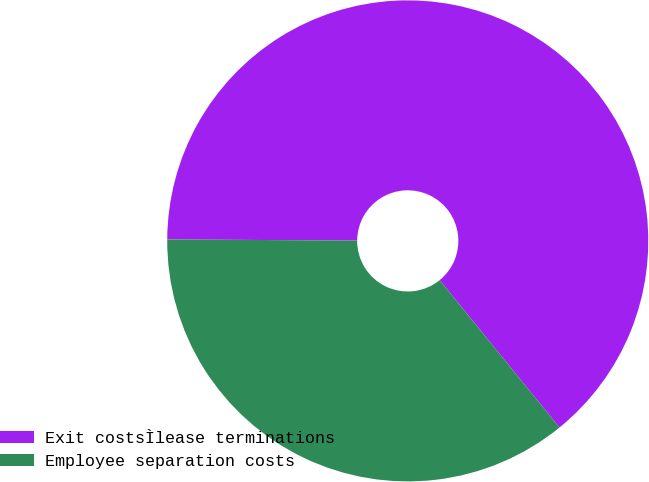Convert chart. <chart><loc_0><loc_0><loc_500><loc_500><pie_chart><fcel>Exit costsÌlease terminations<fcel>Employee separation costs<nl><fcel>64.04%<fcel>35.96%<nl></chart> 